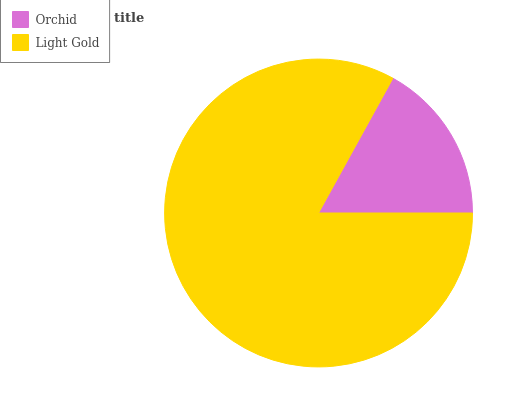Is Orchid the minimum?
Answer yes or no. Yes. Is Light Gold the maximum?
Answer yes or no. Yes. Is Light Gold the minimum?
Answer yes or no. No. Is Light Gold greater than Orchid?
Answer yes or no. Yes. Is Orchid less than Light Gold?
Answer yes or no. Yes. Is Orchid greater than Light Gold?
Answer yes or no. No. Is Light Gold less than Orchid?
Answer yes or no. No. Is Light Gold the high median?
Answer yes or no. Yes. Is Orchid the low median?
Answer yes or no. Yes. Is Orchid the high median?
Answer yes or no. No. Is Light Gold the low median?
Answer yes or no. No. 